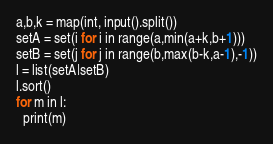Convert code to text. <code><loc_0><loc_0><loc_500><loc_500><_Python_>a,b,k = map(int, input().split())
setA = set(i for i in range(a,min(a+k,b+1)))
setB = set(j for j in range(b,max(b-k,a-1),-1))
l = list(setA|setB)
l.sort()
for m in l:
  print(m)</code> 